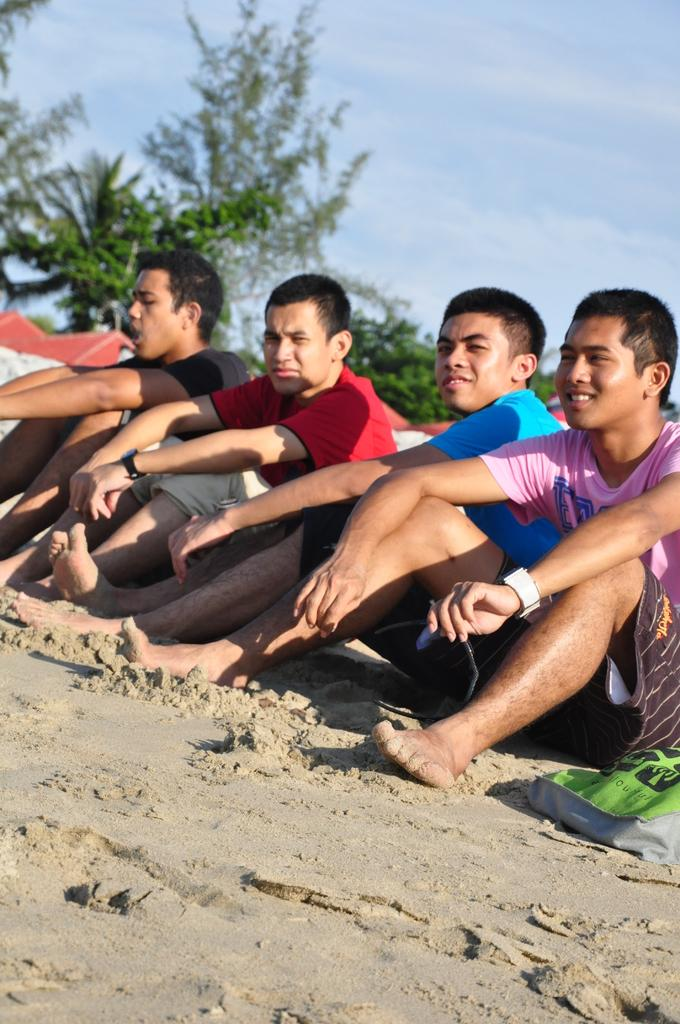What is the main subject of the image? The main subject of the image is a group of boys. Where are the boys located in the image? The boys are sitting on the sea sand in the image. What is the boys' facial expression in the image? The boys are smiling in the image. What are the boys doing in the image? The boys are posing for the camera in the image. What can be seen in the background of the image? There are trees visible in the background of the image. What type of toy can be seen in the hands of the boys in the image? There is no toy visible in the hands of the boys in the image. 